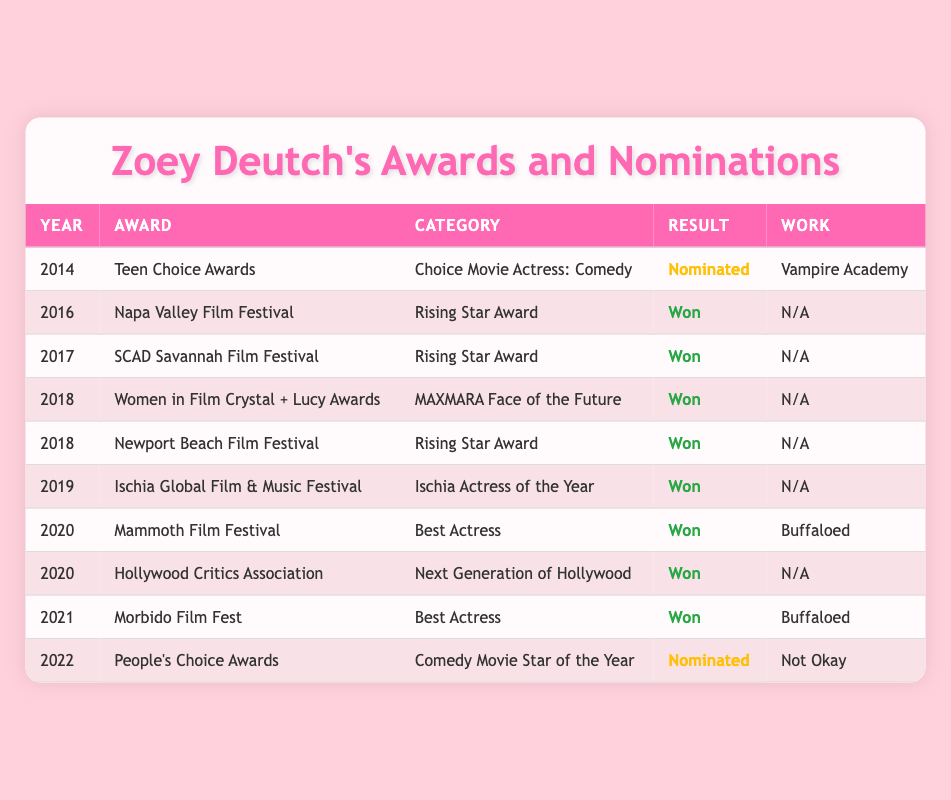What year did Zoey Deutch receive her first nomination? Zoey Deutch's first nomination appears in 2014 at the Teen Choice Awards for Choice Movie Actress: Comedy, as listed in the table.
Answer: 2014 How many awards did Zoey Deutch win in 2020? In 2020, Zoey Deutch won three awards: Best Actress at Mammoth Film Festival, Next Generation of Hollywood at the Hollywood Critics Association, and all are listed in the same year in the table.
Answer: 2 Did Zoey Deutch win at the Napa Valley Film Festival? According to the table, Zoey Deutch won the Rising Star Award at the Napa Valley Film Festival in 2016, which confirms the win.
Answer: Yes What is the total number of nominations Zoey Deutch received? She received two nominations in 2014 and 2022, as listed in the table. Thus, adding these gives a total of 2 nominations.
Answer: 2 Which award was won by Zoey Deutch for her performance in Buffaloed? The table indicates that she won the Best Actress award at the Mammoth Film Festival in 2020 and also won Best Actress at Morbido Film Fest for the same work Buffaloed.
Answer: Best Actress What is the most recent award won by Zoey Deutch? The most recent award won by her according to the table is at the Morbido Film Fest in 2021 for Best Actress, which is the last win mentioned.
Answer: Best Actress How many times has Zoey Deutch won the Rising Star Award? According to the table, Zoey Deutch won the Rising Star Award at both the SCAD Savannah Film Festival in 2017, and at the Newport Beach Film Festival in 2018, indicating she won it twice.
Answer: 2 Which award did Zoey Deutch receive for her role in "Not Okay"? The only mention of "Not Okay" is in 2022 at the People's Choice Awards where she was nominated for Comedy Movie Star of the Year, thus she did not win an award for this film.
Answer: N/A In what year did Zoey Deutch win the MAXMARA Face of the Future award? She won the MAXMARA Face of the Future award in 2018 at the Women in Film Crystal + Lucy Awards, as indicated in the table.
Answer: 2018 